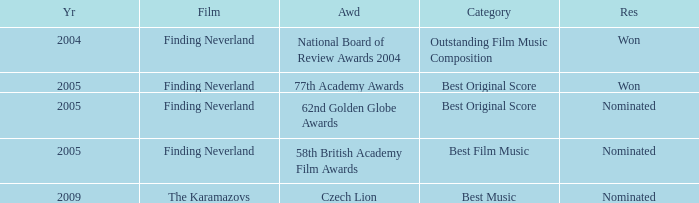What was the result for years prior to 2005? Won. 